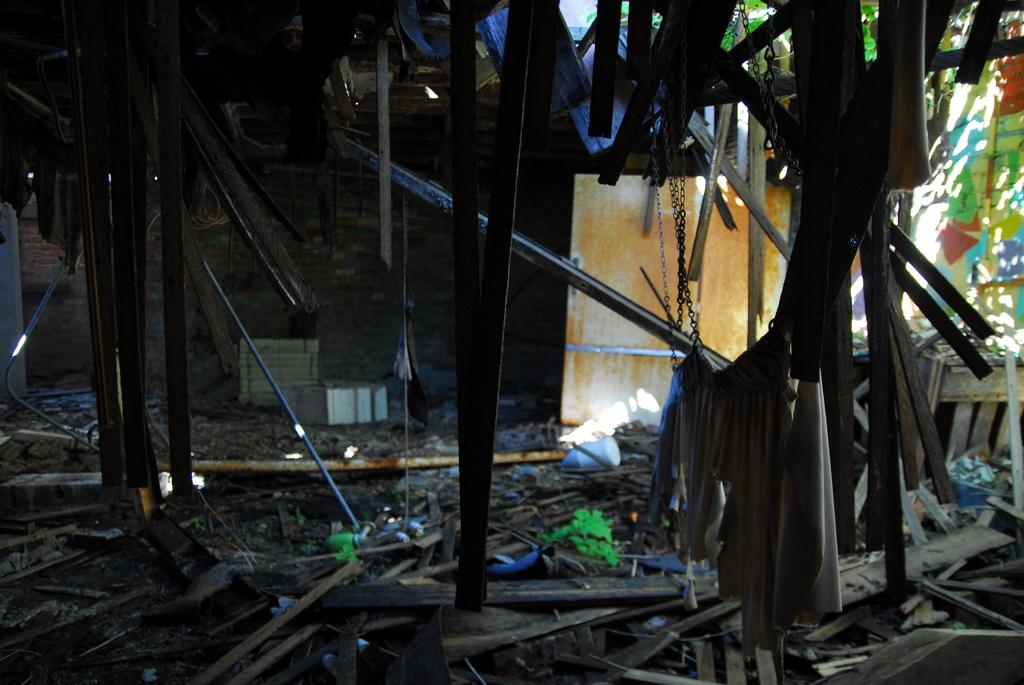What type of material is covering the floor of the damaged shelter? There are wooden pieces on the floor of the damaged shelter. What else can be seen on the floor of the damaged shelter? There is waste on the floor of the damaged shelter. What is the main feature of the background in the image? There is a wooden door in the background. What other objects can be seen in the background of the image? There are other objects visible in the background. How many buttons can be seen on the wooden door in the image? There are no buttons visible on the wooden door in the image. What type of food is the passenger eating in the image? There is no passenger or food present in the image. 